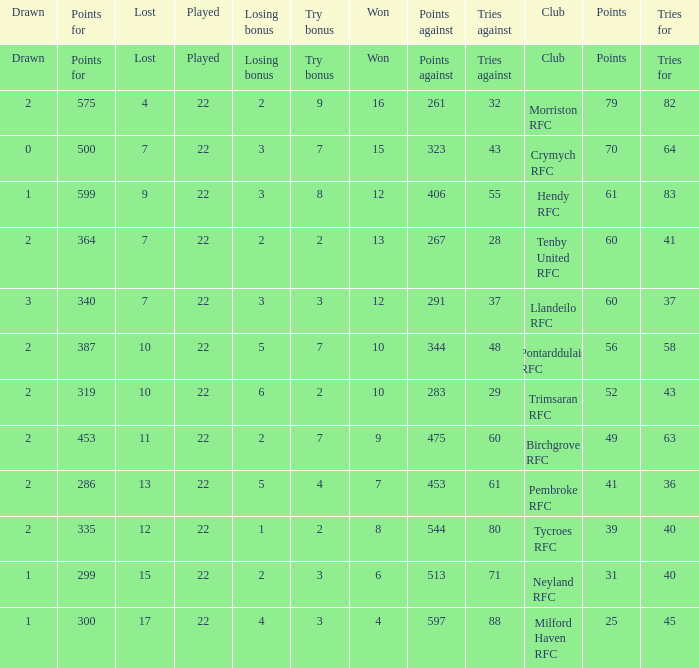 how many points against with tries for being 43 1.0. 